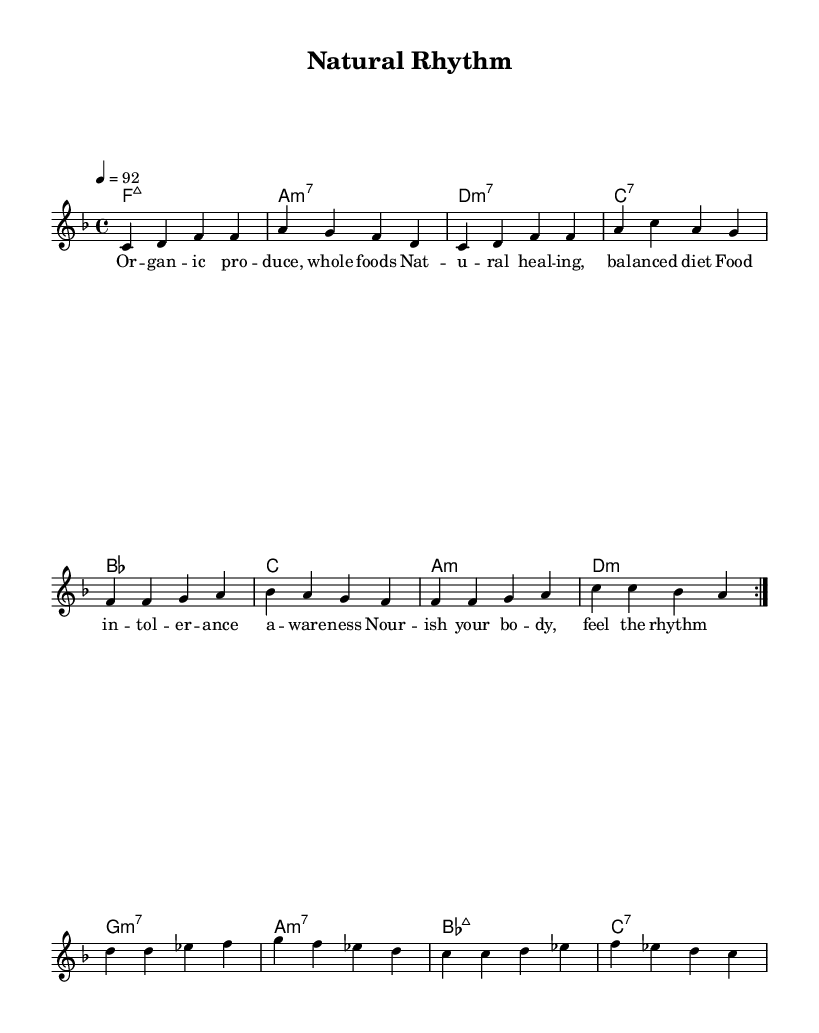What is the key signature of this music? The key signature shows two flats, indicating that the music is in F major. This can be determined by looking at the signature at the beginning of the staff where the flats are placed.
Answer: F major What is the time signature of this music? The time signature is indicated at the beginning of the score, showing 4/4, which means there are four beats in a measure and the quarter note gets one beat.
Answer: 4/4 What is the tempo marking for this piece? The tempo is indicated by the message "4 = 92", which means the quarter note is to be played at 92 beats per minute. This is also located near the beginning of the score.
Answer: 92 What are the first two chords in the piece? Upon examining the harmony section, the first two chords are F major 7 and A minor 7. The chord symbols are listed directly above the melody, indicating the structure of the piece.
Answer: F major 7, A minor 7 How many measures are there in the first volta? The first volta consists of eight measures, as indicated by the repeating section that outlines the melody and harmony. Counting the measures that are repeated confirms this.
Answer: 8 What type of food theme is represented in the lyrics? The lyrics emphasize themes of organic produce and natural healing, which connect the idea of food to health and wellness. The wording directly addresses concepts like food intolerance awareness and a balanced diet.
Answer: Organic produce, natural healing What form does the piece suggest through its lyrics and structure? The song appears to follow a typical verse-chorus structure common in contemporary R&B based on its repeated verses and melodic phrasing. The structure mirrors common forms in rhythm and blues which often emphasize lyrical storytelling.
Answer: Verse-chorus structure 